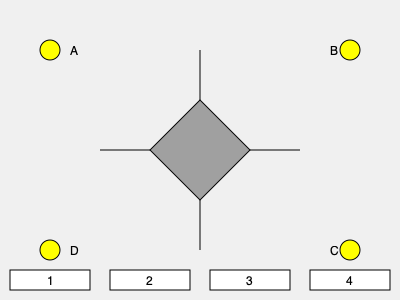Which shadow option (1, 2, 3, or 4) would be cast by the 3D object when the light source is at position C? Explain your reasoning to help students understand the concept of light and shadow formation. To determine the correct shadow cast by the 3D object when the light source is at position C, let's follow these steps:

1. Understand the light source position:
   - Position C is located in the bottom-right corner of the diagram.

2. Analyze the 3D object:
   - The object appears to be a square-based pyramid.
   - It has a square base and four triangular faces meeting at a point (apex).

3. Consider how light travels:
   - Light travels in straight lines from the source.
   - It will cast shadows in the opposite direction from the light source.

4. Predict the shadow shape:
   - With the light coming from the bottom-right, the shadow will be cast towards the top-left.
   - The pyramid's apex will create the farthest point of the shadow.
   - The base of the pyramid will form the edge of the shadow closest to the light source.

5. Compare with given options:
   - Option 1: Shadow pointing down-right (incorrect direction)
   - Option 2: Shadow pointing up-left (correct direction)
   - Option 3: Shadow pointing down-left (incorrect direction)
   - Option 4: Shadow pointing up-right (incorrect direction)

6. Choose the correct option:
   - Option 2 is the only shadow pointing in the correct direction (up-left) and maintaining the general shape of the pyramid's projection.

This exercise helps students visualize how 3D objects cast 2D shadows based on the position of a light source, reinforcing concepts of geometry and light behavior.
Answer: 2 